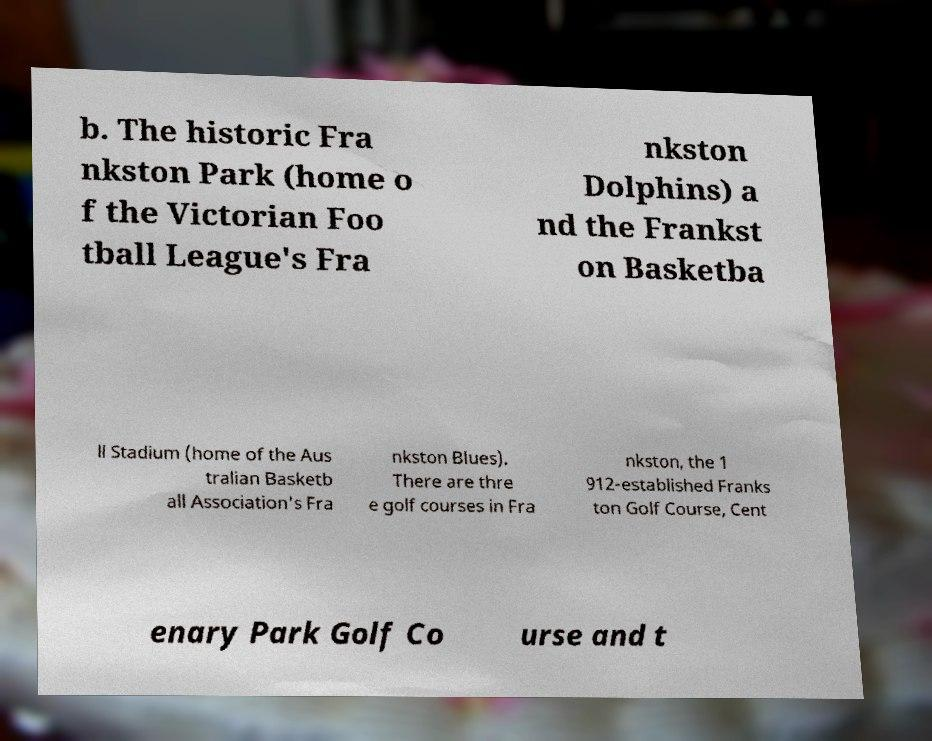What messages or text are displayed in this image? I need them in a readable, typed format. b. The historic Fra nkston Park (home o f the Victorian Foo tball League's Fra nkston Dolphins) a nd the Frankst on Basketba ll Stadium (home of the Aus tralian Basketb all Association's Fra nkston Blues). There are thre e golf courses in Fra nkston, the 1 912-established Franks ton Golf Course, Cent enary Park Golf Co urse and t 